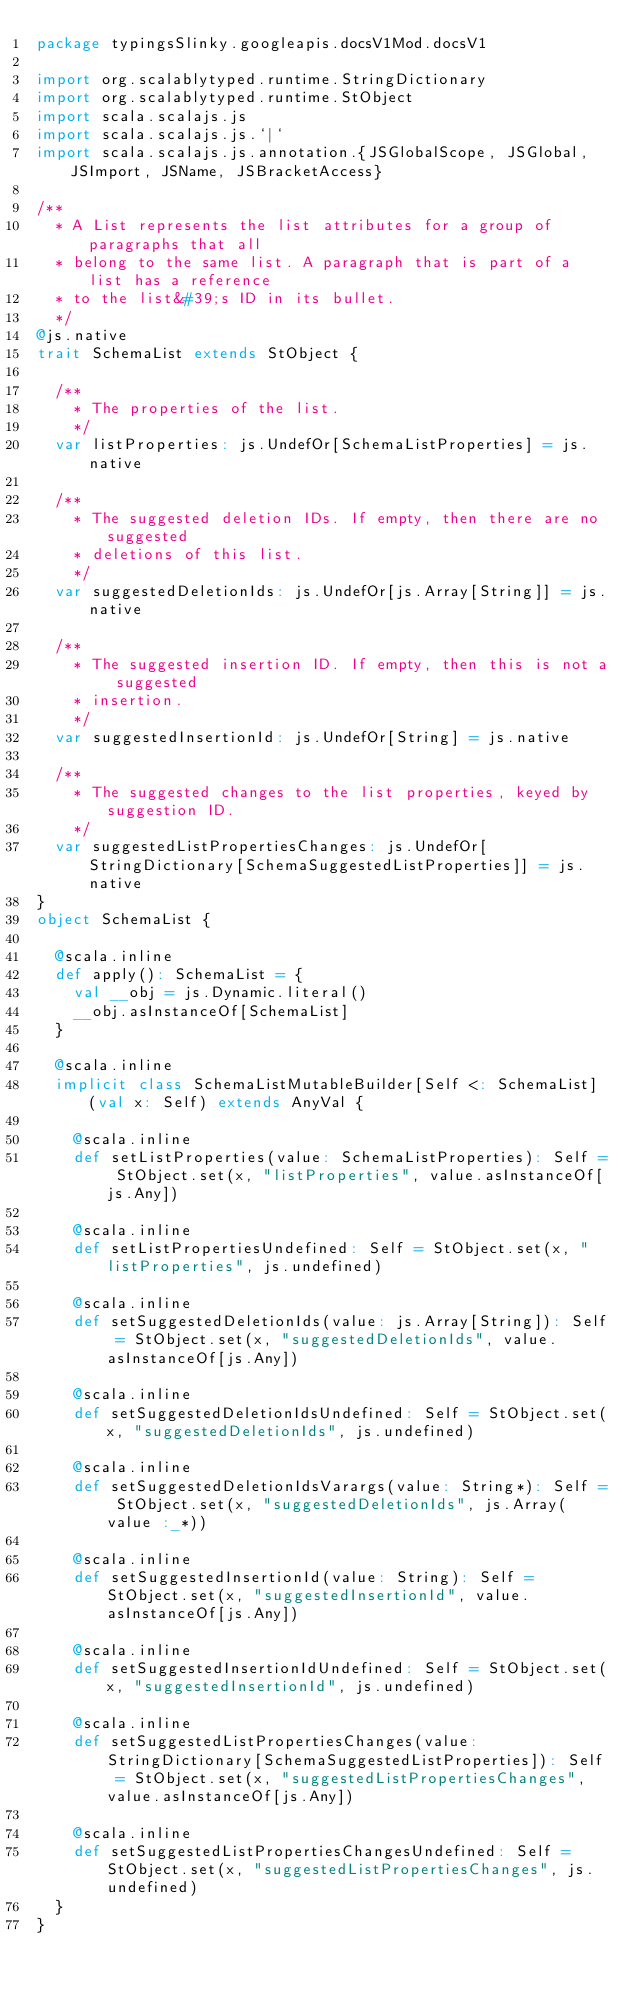<code> <loc_0><loc_0><loc_500><loc_500><_Scala_>package typingsSlinky.googleapis.docsV1Mod.docsV1

import org.scalablytyped.runtime.StringDictionary
import org.scalablytyped.runtime.StObject
import scala.scalajs.js
import scala.scalajs.js.`|`
import scala.scalajs.js.annotation.{JSGlobalScope, JSGlobal, JSImport, JSName, JSBracketAccess}

/**
  * A List represents the list attributes for a group of paragraphs that all
  * belong to the same list. A paragraph that is part of a list has a reference
  * to the list&#39;s ID in its bullet.
  */
@js.native
trait SchemaList extends StObject {
  
  /**
    * The properties of the list.
    */
  var listProperties: js.UndefOr[SchemaListProperties] = js.native
  
  /**
    * The suggested deletion IDs. If empty, then there are no suggested
    * deletions of this list.
    */
  var suggestedDeletionIds: js.UndefOr[js.Array[String]] = js.native
  
  /**
    * The suggested insertion ID. If empty, then this is not a suggested
    * insertion.
    */
  var suggestedInsertionId: js.UndefOr[String] = js.native
  
  /**
    * The suggested changes to the list properties, keyed by suggestion ID.
    */
  var suggestedListPropertiesChanges: js.UndefOr[StringDictionary[SchemaSuggestedListProperties]] = js.native
}
object SchemaList {
  
  @scala.inline
  def apply(): SchemaList = {
    val __obj = js.Dynamic.literal()
    __obj.asInstanceOf[SchemaList]
  }
  
  @scala.inline
  implicit class SchemaListMutableBuilder[Self <: SchemaList] (val x: Self) extends AnyVal {
    
    @scala.inline
    def setListProperties(value: SchemaListProperties): Self = StObject.set(x, "listProperties", value.asInstanceOf[js.Any])
    
    @scala.inline
    def setListPropertiesUndefined: Self = StObject.set(x, "listProperties", js.undefined)
    
    @scala.inline
    def setSuggestedDeletionIds(value: js.Array[String]): Self = StObject.set(x, "suggestedDeletionIds", value.asInstanceOf[js.Any])
    
    @scala.inline
    def setSuggestedDeletionIdsUndefined: Self = StObject.set(x, "suggestedDeletionIds", js.undefined)
    
    @scala.inline
    def setSuggestedDeletionIdsVarargs(value: String*): Self = StObject.set(x, "suggestedDeletionIds", js.Array(value :_*))
    
    @scala.inline
    def setSuggestedInsertionId(value: String): Self = StObject.set(x, "suggestedInsertionId", value.asInstanceOf[js.Any])
    
    @scala.inline
    def setSuggestedInsertionIdUndefined: Self = StObject.set(x, "suggestedInsertionId", js.undefined)
    
    @scala.inline
    def setSuggestedListPropertiesChanges(value: StringDictionary[SchemaSuggestedListProperties]): Self = StObject.set(x, "suggestedListPropertiesChanges", value.asInstanceOf[js.Any])
    
    @scala.inline
    def setSuggestedListPropertiesChangesUndefined: Self = StObject.set(x, "suggestedListPropertiesChanges", js.undefined)
  }
}
</code> 